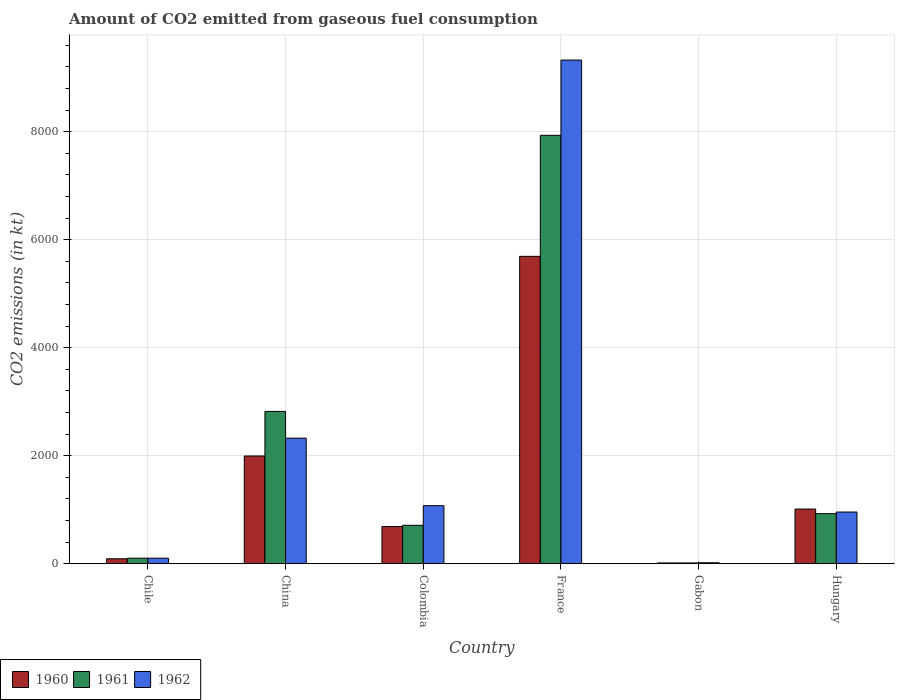How many different coloured bars are there?
Your answer should be compact. 3. Are the number of bars per tick equal to the number of legend labels?
Provide a succinct answer. Yes. Are the number of bars on each tick of the X-axis equal?
Your response must be concise. Yes. How many bars are there on the 4th tick from the right?
Your response must be concise. 3. What is the label of the 1st group of bars from the left?
Make the answer very short. Chile. What is the amount of CO2 emitted in 1960 in China?
Ensure brevity in your answer.  1994.85. Across all countries, what is the maximum amount of CO2 emitted in 1960?
Ensure brevity in your answer.  5691.18. Across all countries, what is the minimum amount of CO2 emitted in 1961?
Your answer should be very brief. 14.67. In which country was the amount of CO2 emitted in 1961 minimum?
Your response must be concise. Gabon. What is the total amount of CO2 emitted in 1962 in the graph?
Keep it short and to the point. 1.38e+04. What is the difference between the amount of CO2 emitted in 1960 in China and that in Colombia?
Your answer should be compact. 1305.45. What is the difference between the amount of CO2 emitted in 1962 in Gabon and the amount of CO2 emitted in 1961 in China?
Provide a succinct answer. -2801.59. What is the average amount of CO2 emitted in 1960 per country?
Give a very brief answer. 1582.31. What is the difference between the amount of CO2 emitted of/in 1961 and amount of CO2 emitted of/in 1962 in Gabon?
Your answer should be compact. -3.67. What is the ratio of the amount of CO2 emitted in 1960 in Colombia to that in France?
Keep it short and to the point. 0.12. Is the amount of CO2 emitted in 1961 in Chile less than that in Colombia?
Your answer should be compact. Yes. Is the difference between the amount of CO2 emitted in 1961 in China and France greater than the difference between the amount of CO2 emitted in 1962 in China and France?
Give a very brief answer. Yes. What is the difference between the highest and the second highest amount of CO2 emitted in 1962?
Provide a short and direct response. -1250.45. What is the difference between the highest and the lowest amount of CO2 emitted in 1960?
Your answer should be very brief. 5676.52. In how many countries, is the amount of CO2 emitted in 1960 greater than the average amount of CO2 emitted in 1960 taken over all countries?
Your response must be concise. 2. Is the sum of the amount of CO2 emitted in 1962 in Chile and China greater than the maximum amount of CO2 emitted in 1960 across all countries?
Provide a short and direct response. No. What does the 1st bar from the left in Hungary represents?
Offer a very short reply. 1960. What does the 3rd bar from the right in Gabon represents?
Make the answer very short. 1960. Is it the case that in every country, the sum of the amount of CO2 emitted in 1960 and amount of CO2 emitted in 1962 is greater than the amount of CO2 emitted in 1961?
Provide a succinct answer. Yes. How many bars are there?
Offer a terse response. 18. Are all the bars in the graph horizontal?
Make the answer very short. No. How many countries are there in the graph?
Offer a very short reply. 6. What is the difference between two consecutive major ticks on the Y-axis?
Ensure brevity in your answer.  2000. Are the values on the major ticks of Y-axis written in scientific E-notation?
Offer a very short reply. No. Does the graph contain grids?
Make the answer very short. Yes. Where does the legend appear in the graph?
Offer a terse response. Bottom left. What is the title of the graph?
Your response must be concise. Amount of CO2 emitted from gaseous fuel consumption. Does "1978" appear as one of the legend labels in the graph?
Your answer should be very brief. No. What is the label or title of the X-axis?
Offer a terse response. Country. What is the label or title of the Y-axis?
Keep it short and to the point. CO2 emissions (in kt). What is the CO2 emissions (in kt) of 1960 in Chile?
Your answer should be very brief. 91.67. What is the CO2 emissions (in kt) in 1961 in Chile?
Offer a very short reply. 102.68. What is the CO2 emissions (in kt) in 1962 in Chile?
Keep it short and to the point. 102.68. What is the CO2 emissions (in kt) in 1960 in China?
Give a very brief answer. 1994.85. What is the CO2 emissions (in kt) of 1961 in China?
Provide a succinct answer. 2819.92. What is the CO2 emissions (in kt) of 1962 in China?
Your answer should be very brief. 2324.88. What is the CO2 emissions (in kt) of 1960 in Colombia?
Your answer should be very brief. 689.4. What is the CO2 emissions (in kt) in 1961 in Colombia?
Provide a succinct answer. 711.4. What is the CO2 emissions (in kt) in 1962 in Colombia?
Offer a terse response. 1074.43. What is the CO2 emissions (in kt) in 1960 in France?
Offer a terse response. 5691.18. What is the CO2 emissions (in kt) in 1961 in France?
Provide a succinct answer. 7931.72. What is the CO2 emissions (in kt) of 1962 in France?
Keep it short and to the point. 9325.18. What is the CO2 emissions (in kt) in 1960 in Gabon?
Give a very brief answer. 14.67. What is the CO2 emissions (in kt) of 1961 in Gabon?
Ensure brevity in your answer.  14.67. What is the CO2 emissions (in kt) in 1962 in Gabon?
Your answer should be compact. 18.34. What is the CO2 emissions (in kt) of 1960 in Hungary?
Offer a very short reply. 1012.09. What is the CO2 emissions (in kt) of 1961 in Hungary?
Ensure brevity in your answer.  927.75. What is the CO2 emissions (in kt) in 1962 in Hungary?
Your answer should be compact. 957.09. Across all countries, what is the maximum CO2 emissions (in kt) in 1960?
Offer a terse response. 5691.18. Across all countries, what is the maximum CO2 emissions (in kt) in 1961?
Give a very brief answer. 7931.72. Across all countries, what is the maximum CO2 emissions (in kt) of 1962?
Give a very brief answer. 9325.18. Across all countries, what is the minimum CO2 emissions (in kt) of 1960?
Keep it short and to the point. 14.67. Across all countries, what is the minimum CO2 emissions (in kt) in 1961?
Provide a short and direct response. 14.67. Across all countries, what is the minimum CO2 emissions (in kt) of 1962?
Provide a succinct answer. 18.34. What is the total CO2 emissions (in kt) in 1960 in the graph?
Provide a short and direct response. 9493.86. What is the total CO2 emissions (in kt) in 1961 in the graph?
Your answer should be very brief. 1.25e+04. What is the total CO2 emissions (in kt) in 1962 in the graph?
Keep it short and to the point. 1.38e+04. What is the difference between the CO2 emissions (in kt) of 1960 in Chile and that in China?
Your answer should be very brief. -1903.17. What is the difference between the CO2 emissions (in kt) in 1961 in Chile and that in China?
Offer a terse response. -2717.25. What is the difference between the CO2 emissions (in kt) of 1962 in Chile and that in China?
Provide a short and direct response. -2222.2. What is the difference between the CO2 emissions (in kt) in 1960 in Chile and that in Colombia?
Make the answer very short. -597.72. What is the difference between the CO2 emissions (in kt) in 1961 in Chile and that in Colombia?
Give a very brief answer. -608.72. What is the difference between the CO2 emissions (in kt) of 1962 in Chile and that in Colombia?
Ensure brevity in your answer.  -971.75. What is the difference between the CO2 emissions (in kt) in 1960 in Chile and that in France?
Your response must be concise. -5599.51. What is the difference between the CO2 emissions (in kt) of 1961 in Chile and that in France?
Provide a short and direct response. -7829.05. What is the difference between the CO2 emissions (in kt) of 1962 in Chile and that in France?
Offer a terse response. -9222.5. What is the difference between the CO2 emissions (in kt) in 1960 in Chile and that in Gabon?
Ensure brevity in your answer.  77.01. What is the difference between the CO2 emissions (in kt) of 1961 in Chile and that in Gabon?
Keep it short and to the point. 88.01. What is the difference between the CO2 emissions (in kt) in 1962 in Chile and that in Gabon?
Give a very brief answer. 84.34. What is the difference between the CO2 emissions (in kt) of 1960 in Chile and that in Hungary?
Your answer should be compact. -920.42. What is the difference between the CO2 emissions (in kt) of 1961 in Chile and that in Hungary?
Give a very brief answer. -825.08. What is the difference between the CO2 emissions (in kt) in 1962 in Chile and that in Hungary?
Your response must be concise. -854.41. What is the difference between the CO2 emissions (in kt) of 1960 in China and that in Colombia?
Keep it short and to the point. 1305.45. What is the difference between the CO2 emissions (in kt) of 1961 in China and that in Colombia?
Provide a short and direct response. 2108.53. What is the difference between the CO2 emissions (in kt) of 1962 in China and that in Colombia?
Your answer should be compact. 1250.45. What is the difference between the CO2 emissions (in kt) of 1960 in China and that in France?
Your answer should be very brief. -3696.34. What is the difference between the CO2 emissions (in kt) of 1961 in China and that in France?
Offer a terse response. -5111.8. What is the difference between the CO2 emissions (in kt) of 1962 in China and that in France?
Your response must be concise. -7000.3. What is the difference between the CO2 emissions (in kt) in 1960 in China and that in Gabon?
Give a very brief answer. 1980.18. What is the difference between the CO2 emissions (in kt) in 1961 in China and that in Gabon?
Give a very brief answer. 2805.26. What is the difference between the CO2 emissions (in kt) in 1962 in China and that in Gabon?
Make the answer very short. 2306.54. What is the difference between the CO2 emissions (in kt) of 1960 in China and that in Hungary?
Provide a succinct answer. 982.76. What is the difference between the CO2 emissions (in kt) in 1961 in China and that in Hungary?
Provide a succinct answer. 1892.17. What is the difference between the CO2 emissions (in kt) in 1962 in China and that in Hungary?
Offer a terse response. 1367.79. What is the difference between the CO2 emissions (in kt) of 1960 in Colombia and that in France?
Make the answer very short. -5001.79. What is the difference between the CO2 emissions (in kt) in 1961 in Colombia and that in France?
Ensure brevity in your answer.  -7220.32. What is the difference between the CO2 emissions (in kt) of 1962 in Colombia and that in France?
Give a very brief answer. -8250.75. What is the difference between the CO2 emissions (in kt) in 1960 in Colombia and that in Gabon?
Your answer should be compact. 674.73. What is the difference between the CO2 emissions (in kt) in 1961 in Colombia and that in Gabon?
Your answer should be very brief. 696.73. What is the difference between the CO2 emissions (in kt) of 1962 in Colombia and that in Gabon?
Your answer should be compact. 1056.1. What is the difference between the CO2 emissions (in kt) of 1960 in Colombia and that in Hungary?
Offer a terse response. -322.7. What is the difference between the CO2 emissions (in kt) in 1961 in Colombia and that in Hungary?
Your answer should be compact. -216.35. What is the difference between the CO2 emissions (in kt) of 1962 in Colombia and that in Hungary?
Offer a very short reply. 117.34. What is the difference between the CO2 emissions (in kt) in 1960 in France and that in Gabon?
Your response must be concise. 5676.52. What is the difference between the CO2 emissions (in kt) of 1961 in France and that in Gabon?
Your response must be concise. 7917.05. What is the difference between the CO2 emissions (in kt) in 1962 in France and that in Gabon?
Provide a short and direct response. 9306.85. What is the difference between the CO2 emissions (in kt) of 1960 in France and that in Hungary?
Provide a short and direct response. 4679.09. What is the difference between the CO2 emissions (in kt) of 1961 in France and that in Hungary?
Give a very brief answer. 7003.97. What is the difference between the CO2 emissions (in kt) of 1962 in France and that in Hungary?
Provide a short and direct response. 8368.09. What is the difference between the CO2 emissions (in kt) of 1960 in Gabon and that in Hungary?
Your response must be concise. -997.42. What is the difference between the CO2 emissions (in kt) in 1961 in Gabon and that in Hungary?
Give a very brief answer. -913.08. What is the difference between the CO2 emissions (in kt) in 1962 in Gabon and that in Hungary?
Offer a terse response. -938.75. What is the difference between the CO2 emissions (in kt) of 1960 in Chile and the CO2 emissions (in kt) of 1961 in China?
Your answer should be very brief. -2728.25. What is the difference between the CO2 emissions (in kt) in 1960 in Chile and the CO2 emissions (in kt) in 1962 in China?
Keep it short and to the point. -2233.2. What is the difference between the CO2 emissions (in kt) in 1961 in Chile and the CO2 emissions (in kt) in 1962 in China?
Provide a short and direct response. -2222.2. What is the difference between the CO2 emissions (in kt) in 1960 in Chile and the CO2 emissions (in kt) in 1961 in Colombia?
Your answer should be very brief. -619.72. What is the difference between the CO2 emissions (in kt) in 1960 in Chile and the CO2 emissions (in kt) in 1962 in Colombia?
Provide a short and direct response. -982.76. What is the difference between the CO2 emissions (in kt) in 1961 in Chile and the CO2 emissions (in kt) in 1962 in Colombia?
Make the answer very short. -971.75. What is the difference between the CO2 emissions (in kt) of 1960 in Chile and the CO2 emissions (in kt) of 1961 in France?
Offer a very short reply. -7840.05. What is the difference between the CO2 emissions (in kt) in 1960 in Chile and the CO2 emissions (in kt) in 1962 in France?
Provide a succinct answer. -9233.51. What is the difference between the CO2 emissions (in kt) of 1961 in Chile and the CO2 emissions (in kt) of 1962 in France?
Ensure brevity in your answer.  -9222.5. What is the difference between the CO2 emissions (in kt) in 1960 in Chile and the CO2 emissions (in kt) in 1961 in Gabon?
Your answer should be compact. 77.01. What is the difference between the CO2 emissions (in kt) of 1960 in Chile and the CO2 emissions (in kt) of 1962 in Gabon?
Your answer should be compact. 73.34. What is the difference between the CO2 emissions (in kt) of 1961 in Chile and the CO2 emissions (in kt) of 1962 in Gabon?
Provide a succinct answer. 84.34. What is the difference between the CO2 emissions (in kt) in 1960 in Chile and the CO2 emissions (in kt) in 1961 in Hungary?
Give a very brief answer. -836.08. What is the difference between the CO2 emissions (in kt) of 1960 in Chile and the CO2 emissions (in kt) of 1962 in Hungary?
Ensure brevity in your answer.  -865.41. What is the difference between the CO2 emissions (in kt) of 1961 in Chile and the CO2 emissions (in kt) of 1962 in Hungary?
Keep it short and to the point. -854.41. What is the difference between the CO2 emissions (in kt) in 1960 in China and the CO2 emissions (in kt) in 1961 in Colombia?
Make the answer very short. 1283.45. What is the difference between the CO2 emissions (in kt) in 1960 in China and the CO2 emissions (in kt) in 1962 in Colombia?
Your response must be concise. 920.42. What is the difference between the CO2 emissions (in kt) of 1961 in China and the CO2 emissions (in kt) of 1962 in Colombia?
Your response must be concise. 1745.49. What is the difference between the CO2 emissions (in kt) of 1960 in China and the CO2 emissions (in kt) of 1961 in France?
Your answer should be very brief. -5936.87. What is the difference between the CO2 emissions (in kt) of 1960 in China and the CO2 emissions (in kt) of 1962 in France?
Keep it short and to the point. -7330.33. What is the difference between the CO2 emissions (in kt) of 1961 in China and the CO2 emissions (in kt) of 1962 in France?
Your answer should be very brief. -6505.26. What is the difference between the CO2 emissions (in kt) of 1960 in China and the CO2 emissions (in kt) of 1961 in Gabon?
Your answer should be very brief. 1980.18. What is the difference between the CO2 emissions (in kt) of 1960 in China and the CO2 emissions (in kt) of 1962 in Gabon?
Offer a very short reply. 1976.51. What is the difference between the CO2 emissions (in kt) of 1961 in China and the CO2 emissions (in kt) of 1962 in Gabon?
Make the answer very short. 2801.59. What is the difference between the CO2 emissions (in kt) of 1960 in China and the CO2 emissions (in kt) of 1961 in Hungary?
Provide a short and direct response. 1067.1. What is the difference between the CO2 emissions (in kt) of 1960 in China and the CO2 emissions (in kt) of 1962 in Hungary?
Your answer should be compact. 1037.76. What is the difference between the CO2 emissions (in kt) in 1961 in China and the CO2 emissions (in kt) in 1962 in Hungary?
Offer a terse response. 1862.84. What is the difference between the CO2 emissions (in kt) in 1960 in Colombia and the CO2 emissions (in kt) in 1961 in France?
Your answer should be compact. -7242.32. What is the difference between the CO2 emissions (in kt) of 1960 in Colombia and the CO2 emissions (in kt) of 1962 in France?
Your answer should be compact. -8635.78. What is the difference between the CO2 emissions (in kt) of 1961 in Colombia and the CO2 emissions (in kt) of 1962 in France?
Offer a terse response. -8613.78. What is the difference between the CO2 emissions (in kt) of 1960 in Colombia and the CO2 emissions (in kt) of 1961 in Gabon?
Provide a short and direct response. 674.73. What is the difference between the CO2 emissions (in kt) of 1960 in Colombia and the CO2 emissions (in kt) of 1962 in Gabon?
Your answer should be compact. 671.06. What is the difference between the CO2 emissions (in kt) in 1961 in Colombia and the CO2 emissions (in kt) in 1962 in Gabon?
Offer a terse response. 693.06. What is the difference between the CO2 emissions (in kt) in 1960 in Colombia and the CO2 emissions (in kt) in 1961 in Hungary?
Make the answer very short. -238.35. What is the difference between the CO2 emissions (in kt) of 1960 in Colombia and the CO2 emissions (in kt) of 1962 in Hungary?
Offer a very short reply. -267.69. What is the difference between the CO2 emissions (in kt) of 1961 in Colombia and the CO2 emissions (in kt) of 1962 in Hungary?
Offer a very short reply. -245.69. What is the difference between the CO2 emissions (in kt) in 1960 in France and the CO2 emissions (in kt) in 1961 in Gabon?
Offer a terse response. 5676.52. What is the difference between the CO2 emissions (in kt) in 1960 in France and the CO2 emissions (in kt) in 1962 in Gabon?
Give a very brief answer. 5672.85. What is the difference between the CO2 emissions (in kt) in 1961 in France and the CO2 emissions (in kt) in 1962 in Gabon?
Your answer should be very brief. 7913.39. What is the difference between the CO2 emissions (in kt) of 1960 in France and the CO2 emissions (in kt) of 1961 in Hungary?
Provide a short and direct response. 4763.43. What is the difference between the CO2 emissions (in kt) in 1960 in France and the CO2 emissions (in kt) in 1962 in Hungary?
Keep it short and to the point. 4734.1. What is the difference between the CO2 emissions (in kt) of 1961 in France and the CO2 emissions (in kt) of 1962 in Hungary?
Provide a short and direct response. 6974.63. What is the difference between the CO2 emissions (in kt) of 1960 in Gabon and the CO2 emissions (in kt) of 1961 in Hungary?
Ensure brevity in your answer.  -913.08. What is the difference between the CO2 emissions (in kt) in 1960 in Gabon and the CO2 emissions (in kt) in 1962 in Hungary?
Your answer should be very brief. -942.42. What is the difference between the CO2 emissions (in kt) of 1961 in Gabon and the CO2 emissions (in kt) of 1962 in Hungary?
Ensure brevity in your answer.  -942.42. What is the average CO2 emissions (in kt) of 1960 per country?
Keep it short and to the point. 1582.31. What is the average CO2 emissions (in kt) of 1961 per country?
Your answer should be very brief. 2084.69. What is the average CO2 emissions (in kt) in 1962 per country?
Your answer should be very brief. 2300.43. What is the difference between the CO2 emissions (in kt) of 1960 and CO2 emissions (in kt) of 1961 in Chile?
Provide a succinct answer. -11. What is the difference between the CO2 emissions (in kt) in 1960 and CO2 emissions (in kt) in 1962 in Chile?
Keep it short and to the point. -11. What is the difference between the CO2 emissions (in kt) of 1961 and CO2 emissions (in kt) of 1962 in Chile?
Make the answer very short. 0. What is the difference between the CO2 emissions (in kt) in 1960 and CO2 emissions (in kt) in 1961 in China?
Ensure brevity in your answer.  -825.08. What is the difference between the CO2 emissions (in kt) in 1960 and CO2 emissions (in kt) in 1962 in China?
Keep it short and to the point. -330.03. What is the difference between the CO2 emissions (in kt) in 1961 and CO2 emissions (in kt) in 1962 in China?
Your response must be concise. 495.05. What is the difference between the CO2 emissions (in kt) in 1960 and CO2 emissions (in kt) in 1961 in Colombia?
Offer a very short reply. -22. What is the difference between the CO2 emissions (in kt) of 1960 and CO2 emissions (in kt) of 1962 in Colombia?
Offer a very short reply. -385.04. What is the difference between the CO2 emissions (in kt) in 1961 and CO2 emissions (in kt) in 1962 in Colombia?
Give a very brief answer. -363.03. What is the difference between the CO2 emissions (in kt) of 1960 and CO2 emissions (in kt) of 1961 in France?
Give a very brief answer. -2240.54. What is the difference between the CO2 emissions (in kt) in 1960 and CO2 emissions (in kt) in 1962 in France?
Provide a short and direct response. -3634. What is the difference between the CO2 emissions (in kt) of 1961 and CO2 emissions (in kt) of 1962 in France?
Provide a short and direct response. -1393.46. What is the difference between the CO2 emissions (in kt) of 1960 and CO2 emissions (in kt) of 1961 in Gabon?
Offer a very short reply. 0. What is the difference between the CO2 emissions (in kt) of 1960 and CO2 emissions (in kt) of 1962 in Gabon?
Give a very brief answer. -3.67. What is the difference between the CO2 emissions (in kt) in 1961 and CO2 emissions (in kt) in 1962 in Gabon?
Ensure brevity in your answer.  -3.67. What is the difference between the CO2 emissions (in kt) of 1960 and CO2 emissions (in kt) of 1961 in Hungary?
Your response must be concise. 84.34. What is the difference between the CO2 emissions (in kt) in 1960 and CO2 emissions (in kt) in 1962 in Hungary?
Offer a very short reply. 55.01. What is the difference between the CO2 emissions (in kt) in 1961 and CO2 emissions (in kt) in 1962 in Hungary?
Offer a terse response. -29.34. What is the ratio of the CO2 emissions (in kt) of 1960 in Chile to that in China?
Provide a short and direct response. 0.05. What is the ratio of the CO2 emissions (in kt) of 1961 in Chile to that in China?
Make the answer very short. 0.04. What is the ratio of the CO2 emissions (in kt) in 1962 in Chile to that in China?
Keep it short and to the point. 0.04. What is the ratio of the CO2 emissions (in kt) of 1960 in Chile to that in Colombia?
Your answer should be very brief. 0.13. What is the ratio of the CO2 emissions (in kt) of 1961 in Chile to that in Colombia?
Offer a terse response. 0.14. What is the ratio of the CO2 emissions (in kt) of 1962 in Chile to that in Colombia?
Your answer should be very brief. 0.1. What is the ratio of the CO2 emissions (in kt) in 1960 in Chile to that in France?
Your response must be concise. 0.02. What is the ratio of the CO2 emissions (in kt) in 1961 in Chile to that in France?
Ensure brevity in your answer.  0.01. What is the ratio of the CO2 emissions (in kt) of 1962 in Chile to that in France?
Your response must be concise. 0.01. What is the ratio of the CO2 emissions (in kt) of 1960 in Chile to that in Gabon?
Your response must be concise. 6.25. What is the ratio of the CO2 emissions (in kt) in 1961 in Chile to that in Gabon?
Offer a very short reply. 7. What is the ratio of the CO2 emissions (in kt) of 1962 in Chile to that in Gabon?
Give a very brief answer. 5.6. What is the ratio of the CO2 emissions (in kt) in 1960 in Chile to that in Hungary?
Provide a short and direct response. 0.09. What is the ratio of the CO2 emissions (in kt) in 1961 in Chile to that in Hungary?
Provide a succinct answer. 0.11. What is the ratio of the CO2 emissions (in kt) in 1962 in Chile to that in Hungary?
Your answer should be very brief. 0.11. What is the ratio of the CO2 emissions (in kt) of 1960 in China to that in Colombia?
Your response must be concise. 2.89. What is the ratio of the CO2 emissions (in kt) of 1961 in China to that in Colombia?
Provide a short and direct response. 3.96. What is the ratio of the CO2 emissions (in kt) in 1962 in China to that in Colombia?
Offer a very short reply. 2.16. What is the ratio of the CO2 emissions (in kt) of 1960 in China to that in France?
Make the answer very short. 0.35. What is the ratio of the CO2 emissions (in kt) of 1961 in China to that in France?
Your answer should be very brief. 0.36. What is the ratio of the CO2 emissions (in kt) of 1962 in China to that in France?
Offer a terse response. 0.25. What is the ratio of the CO2 emissions (in kt) of 1960 in China to that in Gabon?
Make the answer very short. 136. What is the ratio of the CO2 emissions (in kt) of 1961 in China to that in Gabon?
Your response must be concise. 192.25. What is the ratio of the CO2 emissions (in kt) in 1962 in China to that in Gabon?
Your response must be concise. 126.8. What is the ratio of the CO2 emissions (in kt) of 1960 in China to that in Hungary?
Provide a succinct answer. 1.97. What is the ratio of the CO2 emissions (in kt) of 1961 in China to that in Hungary?
Give a very brief answer. 3.04. What is the ratio of the CO2 emissions (in kt) of 1962 in China to that in Hungary?
Ensure brevity in your answer.  2.43. What is the ratio of the CO2 emissions (in kt) of 1960 in Colombia to that in France?
Make the answer very short. 0.12. What is the ratio of the CO2 emissions (in kt) in 1961 in Colombia to that in France?
Ensure brevity in your answer.  0.09. What is the ratio of the CO2 emissions (in kt) of 1962 in Colombia to that in France?
Provide a succinct answer. 0.12. What is the ratio of the CO2 emissions (in kt) in 1961 in Colombia to that in Gabon?
Your answer should be compact. 48.5. What is the ratio of the CO2 emissions (in kt) in 1962 in Colombia to that in Gabon?
Provide a succinct answer. 58.6. What is the ratio of the CO2 emissions (in kt) in 1960 in Colombia to that in Hungary?
Your response must be concise. 0.68. What is the ratio of the CO2 emissions (in kt) in 1961 in Colombia to that in Hungary?
Offer a terse response. 0.77. What is the ratio of the CO2 emissions (in kt) of 1962 in Colombia to that in Hungary?
Make the answer very short. 1.12. What is the ratio of the CO2 emissions (in kt) of 1960 in France to that in Gabon?
Offer a terse response. 388. What is the ratio of the CO2 emissions (in kt) of 1961 in France to that in Gabon?
Provide a succinct answer. 540.75. What is the ratio of the CO2 emissions (in kt) of 1962 in France to that in Gabon?
Ensure brevity in your answer.  508.6. What is the ratio of the CO2 emissions (in kt) in 1960 in France to that in Hungary?
Keep it short and to the point. 5.62. What is the ratio of the CO2 emissions (in kt) in 1961 in France to that in Hungary?
Provide a succinct answer. 8.55. What is the ratio of the CO2 emissions (in kt) of 1962 in France to that in Hungary?
Your answer should be compact. 9.74. What is the ratio of the CO2 emissions (in kt) of 1960 in Gabon to that in Hungary?
Give a very brief answer. 0.01. What is the ratio of the CO2 emissions (in kt) of 1961 in Gabon to that in Hungary?
Ensure brevity in your answer.  0.02. What is the ratio of the CO2 emissions (in kt) in 1962 in Gabon to that in Hungary?
Your response must be concise. 0.02. What is the difference between the highest and the second highest CO2 emissions (in kt) in 1960?
Provide a succinct answer. 3696.34. What is the difference between the highest and the second highest CO2 emissions (in kt) in 1961?
Offer a terse response. 5111.8. What is the difference between the highest and the second highest CO2 emissions (in kt) of 1962?
Ensure brevity in your answer.  7000.3. What is the difference between the highest and the lowest CO2 emissions (in kt) in 1960?
Provide a succinct answer. 5676.52. What is the difference between the highest and the lowest CO2 emissions (in kt) of 1961?
Offer a very short reply. 7917.05. What is the difference between the highest and the lowest CO2 emissions (in kt) in 1962?
Offer a very short reply. 9306.85. 